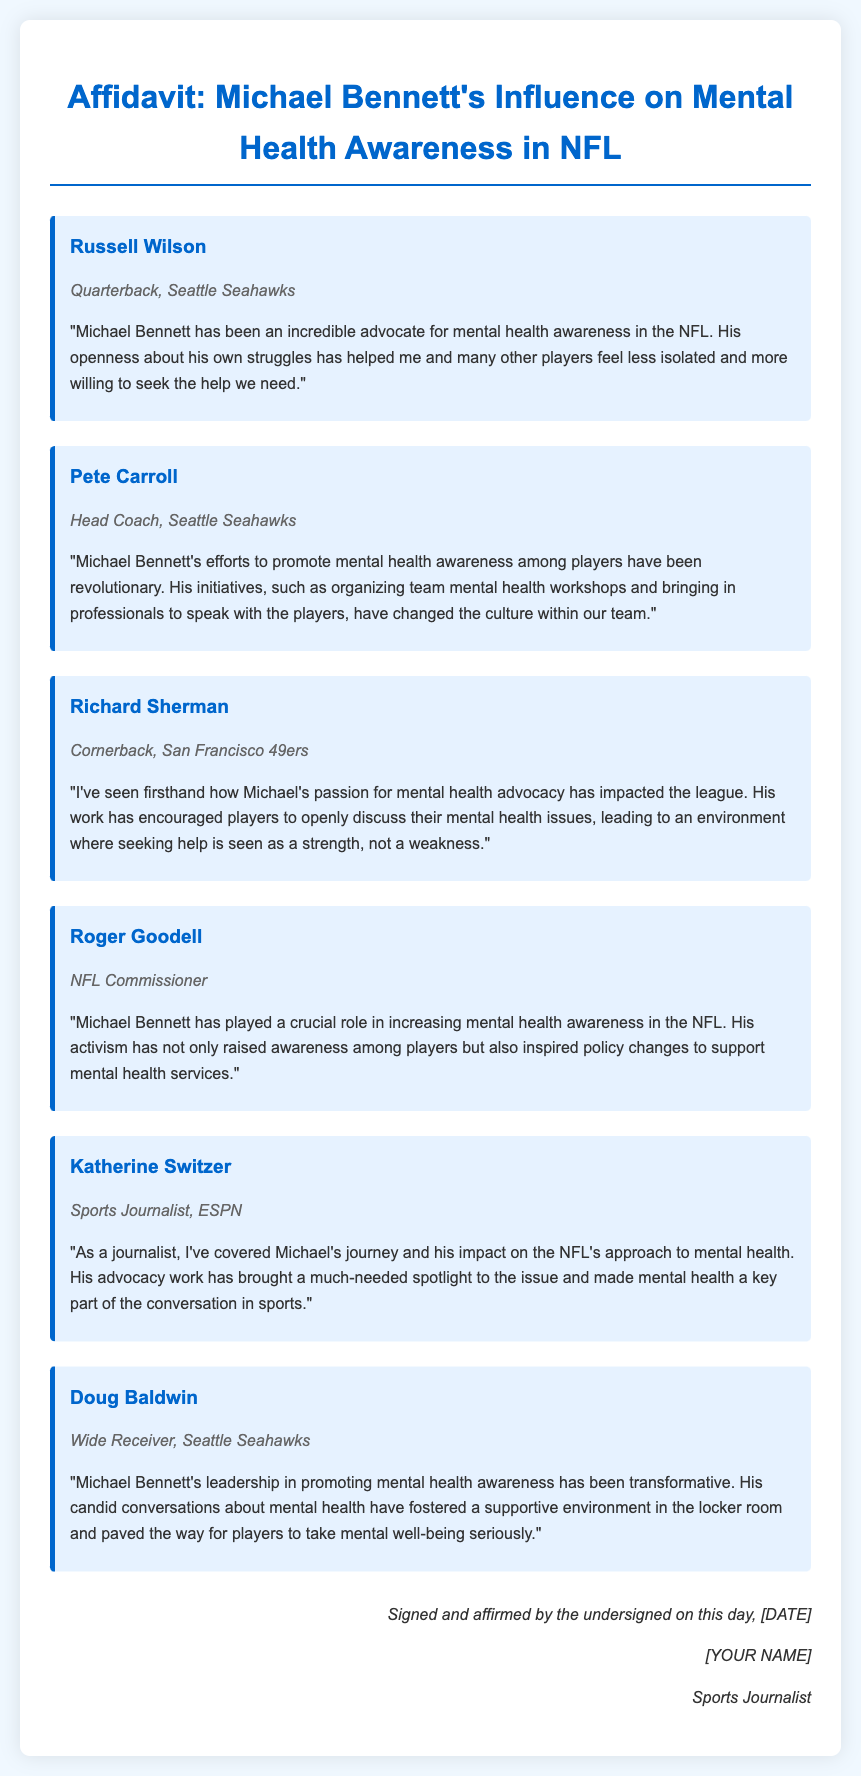What is the title of the document? The title of the document is prominently featured at the top of the affidavit.
Answer: Affidavit: Michael Bennett's Influence on Mental Health Awareness in NFL Who is the head coach mentioned in the document? The document provides the name and position of the head coach who speaks about Michael Bennett's impact.
Answer: Pete Carroll How many testimonials are included in the document? The total number of testimonials can be counted from the document, which features multiple individuals sharing their thoughts.
Answer: Six What profession does Katherine Switzer hold? The document specifies Katherine Switzer's role in relation to Michael Bennett's advocacy.
Answer: Sports Journalist Which player highlighted the environment of discussing mental health as a strength? The document mentions a player who emphasizes the importance of discussing mental health positively in the league.
Answer: Richard Sherman What has Michael Bennett's activism inspired? The document describes a broader impact of Bennett's work apart from individual stories.
Answer: Policy changes What specific activities did Michael Bennett organize? The testimony from Pete Carroll references these specific actions taken to promote mental health awareness.
Answer: Team mental health workshops 